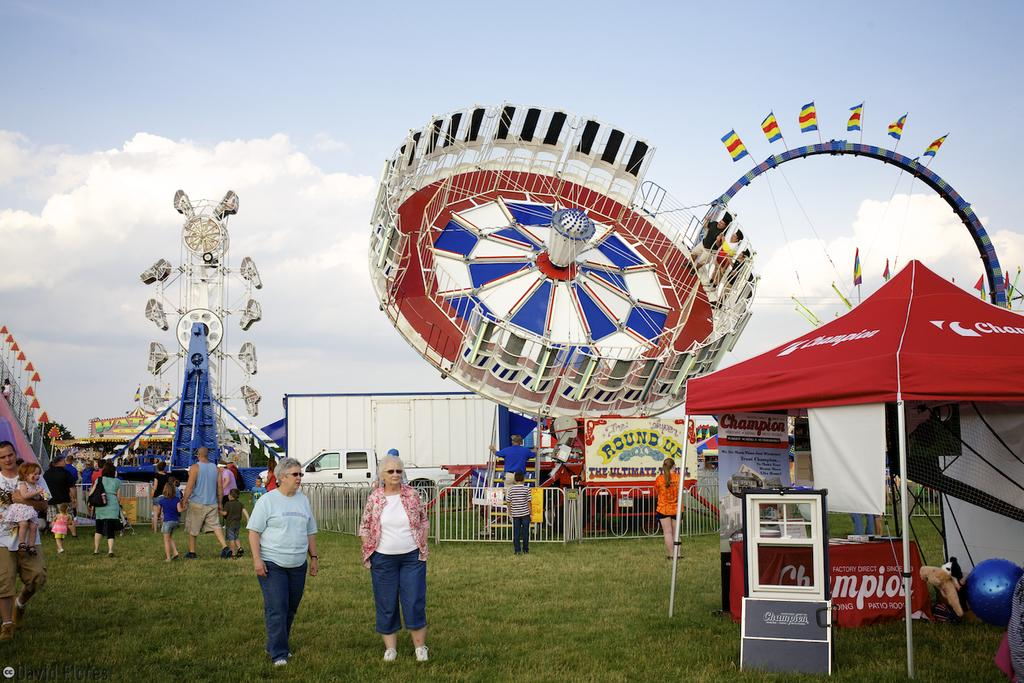Who or what can be seen in the image? There are people in the image. What structures are located on the right side of the image? There are tents on the right side of the image. What type of attractions are visible in the background of the image? There are fun rides in the background of the image. What other structures can be seen in the background of the image? There are sheds in the background of the image. What is visible at the bottom of the image? The ground is visible at the bottom of the image. What type of polish is being applied to the lace in the image? There is no polish or lace present in the image. What kind of paste is being used to hold the fun rides together in the image? There is no paste or indication of construction in the image; the fun rides are already assembled and functioning. 